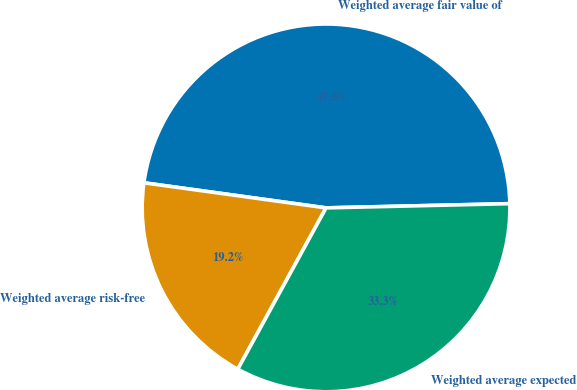Convert chart. <chart><loc_0><loc_0><loc_500><loc_500><pie_chart><fcel>Weighted average fair value of<fcel>Weighted average risk-free<fcel>Weighted average expected<nl><fcel>47.45%<fcel>19.21%<fcel>33.33%<nl></chart> 